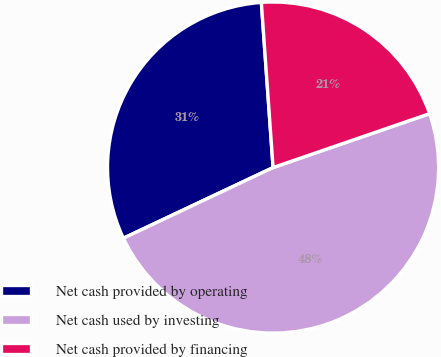<chart> <loc_0><loc_0><loc_500><loc_500><pie_chart><fcel>Net cash provided by operating<fcel>Net cash used by investing<fcel>Net cash provided by financing<nl><fcel>30.89%<fcel>48.26%<fcel>20.85%<nl></chart> 